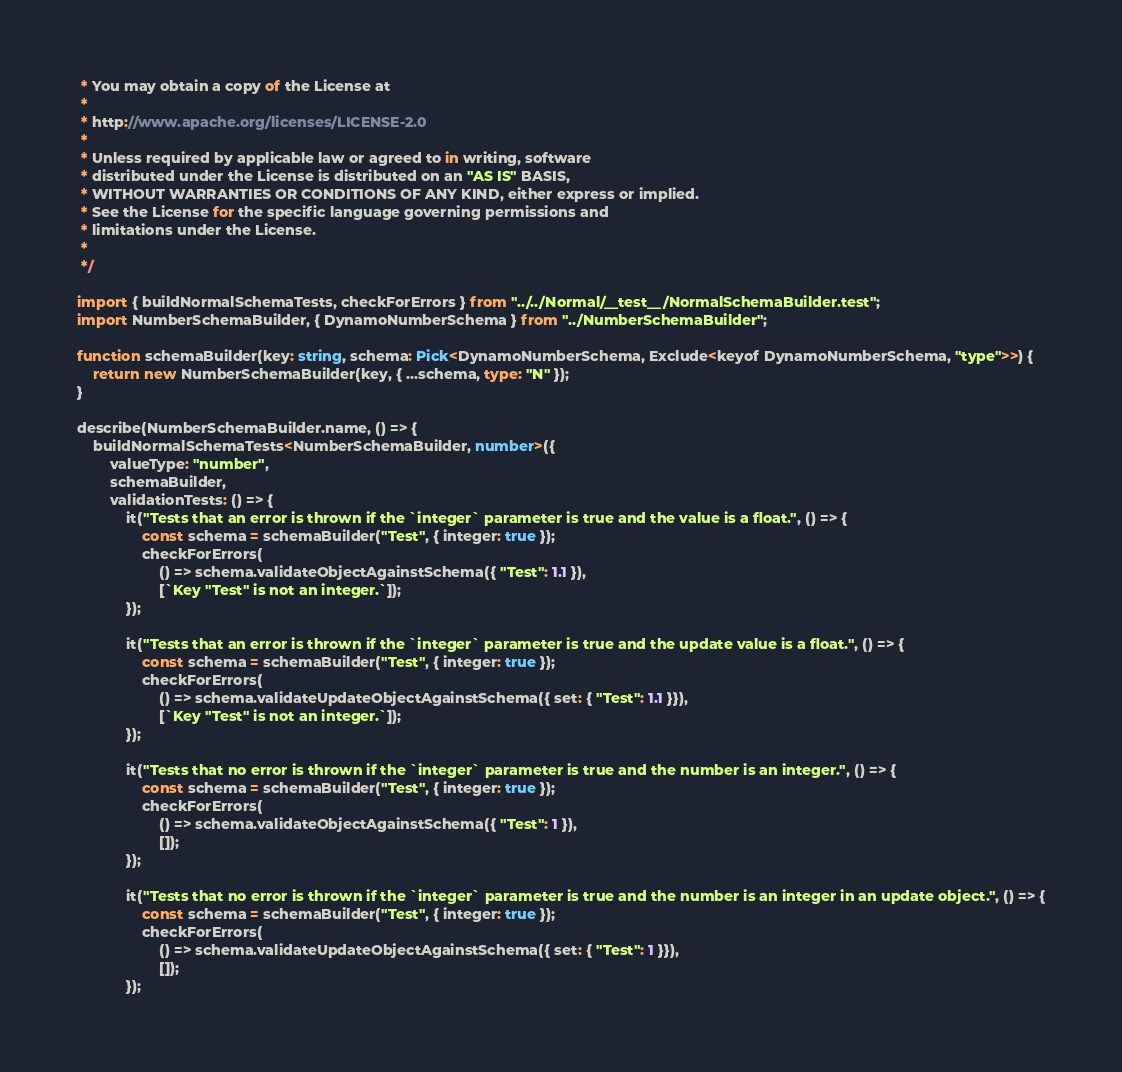<code> <loc_0><loc_0><loc_500><loc_500><_TypeScript_> * You may obtain a copy of the License at
 *
 * http://www.apache.org/licenses/LICENSE-2.0
 *
 * Unless required by applicable law or agreed to in writing, software
 * distributed under the License is distributed on an "AS IS" BASIS,
 * WITHOUT WARRANTIES OR CONDITIONS OF ANY KIND, either express or implied.
 * See the License for the specific language governing permissions and
 * limitations under the License.
 *
 */

import { buildNormalSchemaTests, checkForErrors } from "../../Normal/__test__/NormalSchemaBuilder.test";
import NumberSchemaBuilder, { DynamoNumberSchema } from "../NumberSchemaBuilder";

function schemaBuilder(key: string, schema: Pick<DynamoNumberSchema, Exclude<keyof DynamoNumberSchema, "type">>) {
    return new NumberSchemaBuilder(key, { ...schema, type: "N" });
}

describe(NumberSchemaBuilder.name, () => {
    buildNormalSchemaTests<NumberSchemaBuilder, number>({
        valueType: "number",
        schemaBuilder,
        validationTests: () => {
            it("Tests that an error is thrown if the `integer` parameter is true and the value is a float.", () => {
                const schema = schemaBuilder("Test", { integer: true });
                checkForErrors(
                    () => schema.validateObjectAgainstSchema({ "Test": 1.1 }),
                    [`Key "Test" is not an integer.`]);
            });

            it("Tests that an error is thrown if the `integer` parameter is true and the update value is a float.", () => {
                const schema = schemaBuilder("Test", { integer: true });
                checkForErrors(
                    () => schema.validateUpdateObjectAgainstSchema({ set: { "Test": 1.1 }}),
                    [`Key "Test" is not an integer.`]);
            });

            it("Tests that no error is thrown if the `integer` parameter is true and the number is an integer.", () => {
                const schema = schemaBuilder("Test", { integer: true });
                checkForErrors(
                    () => schema.validateObjectAgainstSchema({ "Test": 1 }),
                    []);
            });

            it("Tests that no error is thrown if the `integer` parameter is true and the number is an integer in an update object.", () => {
                const schema = schemaBuilder("Test", { integer: true });
                checkForErrors(
                    () => schema.validateUpdateObjectAgainstSchema({ set: { "Test": 1 }}),
                    []);
            });
</code> 